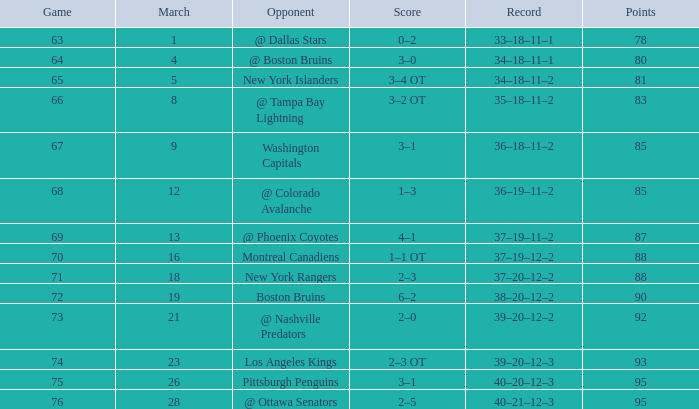How many points hold a record of 40-21-12-3, and a march more than 28? 0.0. 